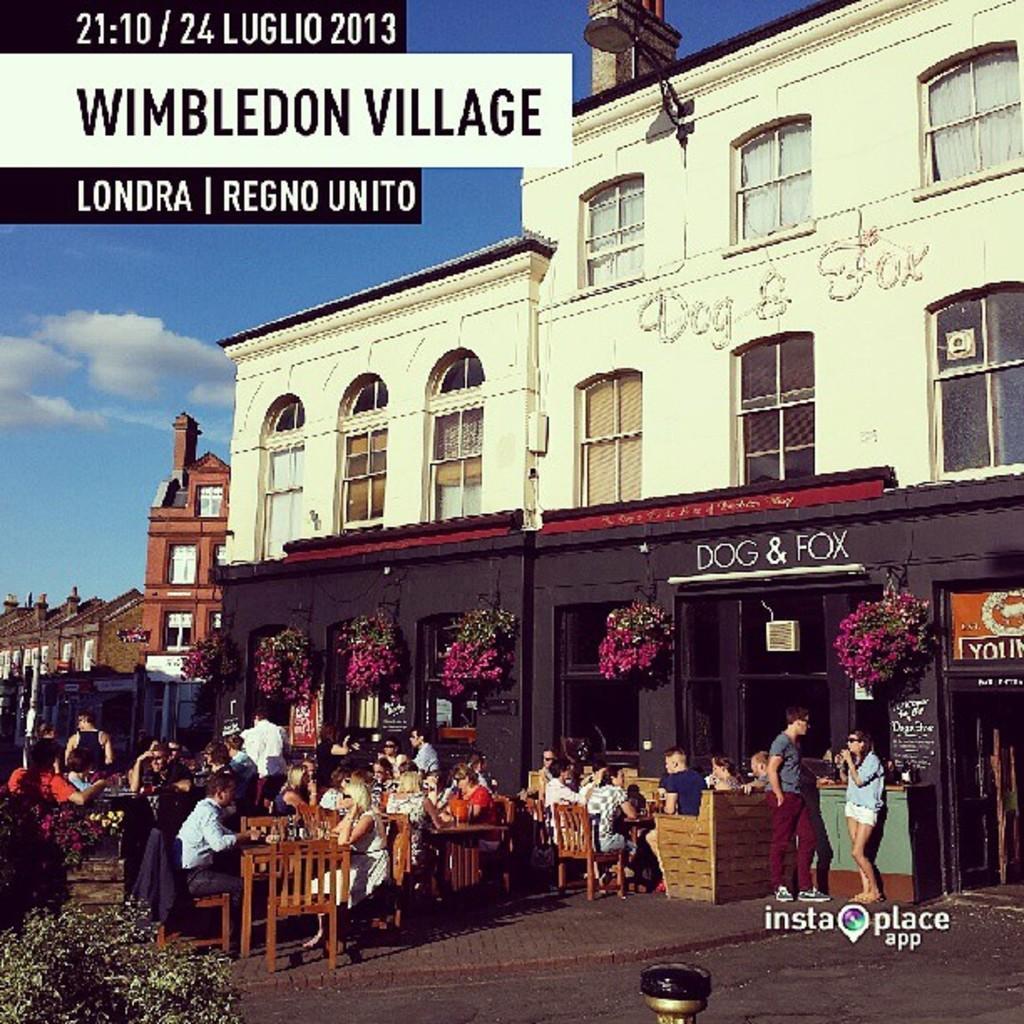How would you summarize this image in a sentence or two? In this picture I can see there are crowd of people here and they are sitting in the chair and they have tables in front of him and there are some buildings, windows and the sky is clear. 